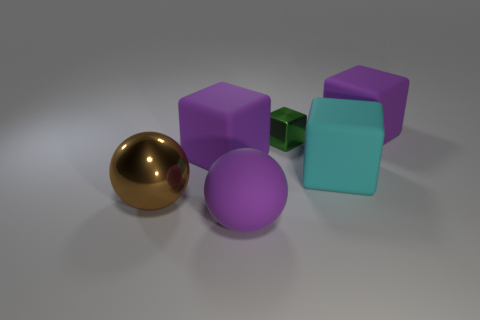Subtract 1 cubes. How many cubes are left? 3 Add 4 brown objects. How many objects exist? 10 Subtract all blocks. How many objects are left? 2 Add 2 large purple matte objects. How many large purple matte objects are left? 5 Add 4 large purple things. How many large purple things exist? 7 Subtract 0 purple cylinders. How many objects are left? 6 Subtract all big yellow rubber cylinders. Subtract all cubes. How many objects are left? 2 